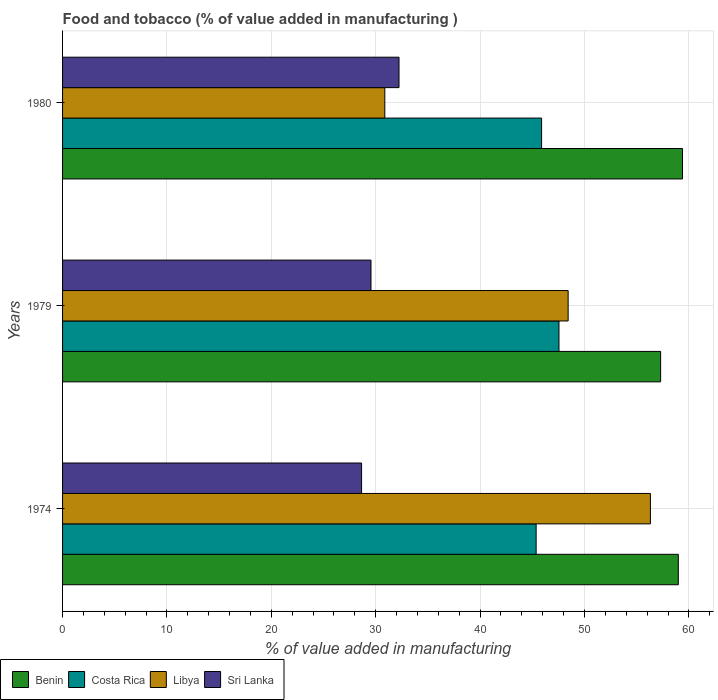How many different coloured bars are there?
Your answer should be very brief. 4. Are the number of bars per tick equal to the number of legend labels?
Your answer should be compact. Yes. How many bars are there on the 2nd tick from the top?
Keep it short and to the point. 4. How many bars are there on the 1st tick from the bottom?
Keep it short and to the point. 4. What is the label of the 2nd group of bars from the top?
Your response must be concise. 1979. What is the value added in manufacturing food and tobacco in Costa Rica in 1974?
Offer a terse response. 45.37. Across all years, what is the maximum value added in manufacturing food and tobacco in Sri Lanka?
Ensure brevity in your answer.  32.23. Across all years, what is the minimum value added in manufacturing food and tobacco in Benin?
Keep it short and to the point. 57.29. In which year was the value added in manufacturing food and tobacco in Sri Lanka maximum?
Provide a short and direct response. 1980. In which year was the value added in manufacturing food and tobacco in Costa Rica minimum?
Provide a short and direct response. 1974. What is the total value added in manufacturing food and tobacco in Costa Rica in the graph?
Provide a succinct answer. 138.81. What is the difference between the value added in manufacturing food and tobacco in Libya in 1974 and that in 1979?
Provide a short and direct response. 7.88. What is the difference between the value added in manufacturing food and tobacco in Sri Lanka in 1979 and the value added in manufacturing food and tobacco in Libya in 1974?
Provide a short and direct response. -26.77. What is the average value added in manufacturing food and tobacco in Costa Rica per year?
Give a very brief answer. 46.27. In the year 1974, what is the difference between the value added in manufacturing food and tobacco in Libya and value added in manufacturing food and tobacco in Sri Lanka?
Keep it short and to the point. 27.67. In how many years, is the value added in manufacturing food and tobacco in Benin greater than 12 %?
Make the answer very short. 3. What is the ratio of the value added in manufacturing food and tobacco in Costa Rica in 1974 to that in 1980?
Offer a very short reply. 0.99. Is the value added in manufacturing food and tobacco in Costa Rica in 1974 less than that in 1980?
Keep it short and to the point. Yes. Is the difference between the value added in manufacturing food and tobacco in Libya in 1974 and 1979 greater than the difference between the value added in manufacturing food and tobacco in Sri Lanka in 1974 and 1979?
Offer a very short reply. Yes. What is the difference between the highest and the second highest value added in manufacturing food and tobacco in Benin?
Provide a short and direct response. 0.4. What is the difference between the highest and the lowest value added in manufacturing food and tobacco in Costa Rica?
Your response must be concise. 2.19. In how many years, is the value added in manufacturing food and tobacco in Benin greater than the average value added in manufacturing food and tobacco in Benin taken over all years?
Your response must be concise. 2. What does the 4th bar from the top in 1979 represents?
Your response must be concise. Benin. What does the 4th bar from the bottom in 1979 represents?
Provide a short and direct response. Sri Lanka. How many years are there in the graph?
Offer a very short reply. 3. Does the graph contain grids?
Your response must be concise. Yes. Where does the legend appear in the graph?
Your response must be concise. Bottom left. What is the title of the graph?
Offer a very short reply. Food and tobacco (% of value added in manufacturing ). Does "Bosnia and Herzegovina" appear as one of the legend labels in the graph?
Make the answer very short. No. What is the label or title of the X-axis?
Provide a succinct answer. % of value added in manufacturing. What is the % of value added in manufacturing of Benin in 1974?
Your answer should be very brief. 58.99. What is the % of value added in manufacturing in Costa Rica in 1974?
Make the answer very short. 45.37. What is the % of value added in manufacturing in Libya in 1974?
Offer a terse response. 56.32. What is the % of value added in manufacturing of Sri Lanka in 1974?
Your response must be concise. 28.65. What is the % of value added in manufacturing of Benin in 1979?
Provide a short and direct response. 57.29. What is the % of value added in manufacturing in Costa Rica in 1979?
Keep it short and to the point. 47.56. What is the % of value added in manufacturing in Libya in 1979?
Provide a succinct answer. 48.43. What is the % of value added in manufacturing of Sri Lanka in 1979?
Ensure brevity in your answer.  29.55. What is the % of value added in manufacturing of Benin in 1980?
Your response must be concise. 59.39. What is the % of value added in manufacturing of Costa Rica in 1980?
Your response must be concise. 45.89. What is the % of value added in manufacturing in Libya in 1980?
Provide a short and direct response. 30.87. What is the % of value added in manufacturing in Sri Lanka in 1980?
Your answer should be very brief. 32.23. Across all years, what is the maximum % of value added in manufacturing in Benin?
Your answer should be very brief. 59.39. Across all years, what is the maximum % of value added in manufacturing in Costa Rica?
Your answer should be compact. 47.56. Across all years, what is the maximum % of value added in manufacturing in Libya?
Your response must be concise. 56.32. Across all years, what is the maximum % of value added in manufacturing of Sri Lanka?
Make the answer very short. 32.23. Across all years, what is the minimum % of value added in manufacturing in Benin?
Your response must be concise. 57.29. Across all years, what is the minimum % of value added in manufacturing in Costa Rica?
Your answer should be very brief. 45.37. Across all years, what is the minimum % of value added in manufacturing of Libya?
Offer a very short reply. 30.87. Across all years, what is the minimum % of value added in manufacturing of Sri Lanka?
Your answer should be compact. 28.65. What is the total % of value added in manufacturing of Benin in the graph?
Provide a short and direct response. 175.67. What is the total % of value added in manufacturing in Costa Rica in the graph?
Your answer should be compact. 138.81. What is the total % of value added in manufacturing of Libya in the graph?
Your answer should be very brief. 135.62. What is the total % of value added in manufacturing in Sri Lanka in the graph?
Give a very brief answer. 90.42. What is the difference between the % of value added in manufacturing of Benin in 1974 and that in 1979?
Your answer should be very brief. 1.69. What is the difference between the % of value added in manufacturing in Costa Rica in 1974 and that in 1979?
Offer a very short reply. -2.19. What is the difference between the % of value added in manufacturing in Libya in 1974 and that in 1979?
Offer a terse response. 7.88. What is the difference between the % of value added in manufacturing in Sri Lanka in 1974 and that in 1979?
Give a very brief answer. -0.9. What is the difference between the % of value added in manufacturing in Benin in 1974 and that in 1980?
Provide a short and direct response. -0.4. What is the difference between the % of value added in manufacturing in Costa Rica in 1974 and that in 1980?
Your answer should be very brief. -0.52. What is the difference between the % of value added in manufacturing in Libya in 1974 and that in 1980?
Ensure brevity in your answer.  25.44. What is the difference between the % of value added in manufacturing in Sri Lanka in 1974 and that in 1980?
Make the answer very short. -3.59. What is the difference between the % of value added in manufacturing in Benin in 1979 and that in 1980?
Provide a short and direct response. -2.09. What is the difference between the % of value added in manufacturing of Costa Rica in 1979 and that in 1980?
Your response must be concise. 1.66. What is the difference between the % of value added in manufacturing in Libya in 1979 and that in 1980?
Keep it short and to the point. 17.56. What is the difference between the % of value added in manufacturing in Sri Lanka in 1979 and that in 1980?
Provide a succinct answer. -2.68. What is the difference between the % of value added in manufacturing of Benin in 1974 and the % of value added in manufacturing of Costa Rica in 1979?
Give a very brief answer. 11.43. What is the difference between the % of value added in manufacturing in Benin in 1974 and the % of value added in manufacturing in Libya in 1979?
Offer a terse response. 10.55. What is the difference between the % of value added in manufacturing of Benin in 1974 and the % of value added in manufacturing of Sri Lanka in 1979?
Your response must be concise. 29.44. What is the difference between the % of value added in manufacturing in Costa Rica in 1974 and the % of value added in manufacturing in Libya in 1979?
Your response must be concise. -3.07. What is the difference between the % of value added in manufacturing of Costa Rica in 1974 and the % of value added in manufacturing of Sri Lanka in 1979?
Provide a succinct answer. 15.82. What is the difference between the % of value added in manufacturing of Libya in 1974 and the % of value added in manufacturing of Sri Lanka in 1979?
Keep it short and to the point. 26.77. What is the difference between the % of value added in manufacturing of Benin in 1974 and the % of value added in manufacturing of Costa Rica in 1980?
Provide a succinct answer. 13.1. What is the difference between the % of value added in manufacturing in Benin in 1974 and the % of value added in manufacturing in Libya in 1980?
Provide a short and direct response. 28.12. What is the difference between the % of value added in manufacturing of Benin in 1974 and the % of value added in manufacturing of Sri Lanka in 1980?
Your answer should be very brief. 26.76. What is the difference between the % of value added in manufacturing in Costa Rica in 1974 and the % of value added in manufacturing in Libya in 1980?
Ensure brevity in your answer.  14.5. What is the difference between the % of value added in manufacturing of Costa Rica in 1974 and the % of value added in manufacturing of Sri Lanka in 1980?
Your answer should be compact. 13.14. What is the difference between the % of value added in manufacturing in Libya in 1974 and the % of value added in manufacturing in Sri Lanka in 1980?
Offer a terse response. 24.08. What is the difference between the % of value added in manufacturing of Benin in 1979 and the % of value added in manufacturing of Costa Rica in 1980?
Offer a terse response. 11.4. What is the difference between the % of value added in manufacturing of Benin in 1979 and the % of value added in manufacturing of Libya in 1980?
Keep it short and to the point. 26.42. What is the difference between the % of value added in manufacturing in Benin in 1979 and the % of value added in manufacturing in Sri Lanka in 1980?
Offer a terse response. 25.06. What is the difference between the % of value added in manufacturing in Costa Rica in 1979 and the % of value added in manufacturing in Libya in 1980?
Keep it short and to the point. 16.68. What is the difference between the % of value added in manufacturing of Costa Rica in 1979 and the % of value added in manufacturing of Sri Lanka in 1980?
Keep it short and to the point. 15.32. What is the difference between the % of value added in manufacturing of Libya in 1979 and the % of value added in manufacturing of Sri Lanka in 1980?
Give a very brief answer. 16.2. What is the average % of value added in manufacturing in Benin per year?
Ensure brevity in your answer.  58.56. What is the average % of value added in manufacturing in Costa Rica per year?
Make the answer very short. 46.27. What is the average % of value added in manufacturing in Libya per year?
Offer a very short reply. 45.21. What is the average % of value added in manufacturing of Sri Lanka per year?
Give a very brief answer. 30.14. In the year 1974, what is the difference between the % of value added in manufacturing in Benin and % of value added in manufacturing in Costa Rica?
Keep it short and to the point. 13.62. In the year 1974, what is the difference between the % of value added in manufacturing in Benin and % of value added in manufacturing in Libya?
Give a very brief answer. 2.67. In the year 1974, what is the difference between the % of value added in manufacturing of Benin and % of value added in manufacturing of Sri Lanka?
Give a very brief answer. 30.34. In the year 1974, what is the difference between the % of value added in manufacturing in Costa Rica and % of value added in manufacturing in Libya?
Provide a succinct answer. -10.95. In the year 1974, what is the difference between the % of value added in manufacturing of Costa Rica and % of value added in manufacturing of Sri Lanka?
Give a very brief answer. 16.72. In the year 1974, what is the difference between the % of value added in manufacturing in Libya and % of value added in manufacturing in Sri Lanka?
Keep it short and to the point. 27.67. In the year 1979, what is the difference between the % of value added in manufacturing in Benin and % of value added in manufacturing in Costa Rica?
Make the answer very short. 9.74. In the year 1979, what is the difference between the % of value added in manufacturing in Benin and % of value added in manufacturing in Libya?
Your response must be concise. 8.86. In the year 1979, what is the difference between the % of value added in manufacturing in Benin and % of value added in manufacturing in Sri Lanka?
Provide a short and direct response. 27.75. In the year 1979, what is the difference between the % of value added in manufacturing of Costa Rica and % of value added in manufacturing of Libya?
Provide a short and direct response. -0.88. In the year 1979, what is the difference between the % of value added in manufacturing in Costa Rica and % of value added in manufacturing in Sri Lanka?
Your response must be concise. 18.01. In the year 1979, what is the difference between the % of value added in manufacturing of Libya and % of value added in manufacturing of Sri Lanka?
Offer a terse response. 18.89. In the year 1980, what is the difference between the % of value added in manufacturing in Benin and % of value added in manufacturing in Costa Rica?
Provide a short and direct response. 13.5. In the year 1980, what is the difference between the % of value added in manufacturing of Benin and % of value added in manufacturing of Libya?
Your response must be concise. 28.52. In the year 1980, what is the difference between the % of value added in manufacturing of Benin and % of value added in manufacturing of Sri Lanka?
Give a very brief answer. 27.16. In the year 1980, what is the difference between the % of value added in manufacturing in Costa Rica and % of value added in manufacturing in Libya?
Give a very brief answer. 15.02. In the year 1980, what is the difference between the % of value added in manufacturing in Costa Rica and % of value added in manufacturing in Sri Lanka?
Offer a very short reply. 13.66. In the year 1980, what is the difference between the % of value added in manufacturing of Libya and % of value added in manufacturing of Sri Lanka?
Give a very brief answer. -1.36. What is the ratio of the % of value added in manufacturing in Benin in 1974 to that in 1979?
Provide a succinct answer. 1.03. What is the ratio of the % of value added in manufacturing of Costa Rica in 1974 to that in 1979?
Your response must be concise. 0.95. What is the ratio of the % of value added in manufacturing in Libya in 1974 to that in 1979?
Ensure brevity in your answer.  1.16. What is the ratio of the % of value added in manufacturing of Sri Lanka in 1974 to that in 1979?
Your answer should be very brief. 0.97. What is the ratio of the % of value added in manufacturing in Costa Rica in 1974 to that in 1980?
Provide a succinct answer. 0.99. What is the ratio of the % of value added in manufacturing of Libya in 1974 to that in 1980?
Your answer should be very brief. 1.82. What is the ratio of the % of value added in manufacturing of Sri Lanka in 1974 to that in 1980?
Your answer should be very brief. 0.89. What is the ratio of the % of value added in manufacturing of Benin in 1979 to that in 1980?
Make the answer very short. 0.96. What is the ratio of the % of value added in manufacturing of Costa Rica in 1979 to that in 1980?
Make the answer very short. 1.04. What is the ratio of the % of value added in manufacturing in Libya in 1979 to that in 1980?
Provide a succinct answer. 1.57. What is the difference between the highest and the second highest % of value added in manufacturing of Benin?
Ensure brevity in your answer.  0.4. What is the difference between the highest and the second highest % of value added in manufacturing of Costa Rica?
Provide a succinct answer. 1.66. What is the difference between the highest and the second highest % of value added in manufacturing of Libya?
Keep it short and to the point. 7.88. What is the difference between the highest and the second highest % of value added in manufacturing in Sri Lanka?
Your answer should be compact. 2.68. What is the difference between the highest and the lowest % of value added in manufacturing in Benin?
Offer a terse response. 2.09. What is the difference between the highest and the lowest % of value added in manufacturing in Costa Rica?
Your answer should be very brief. 2.19. What is the difference between the highest and the lowest % of value added in manufacturing of Libya?
Your answer should be compact. 25.44. What is the difference between the highest and the lowest % of value added in manufacturing in Sri Lanka?
Offer a very short reply. 3.59. 